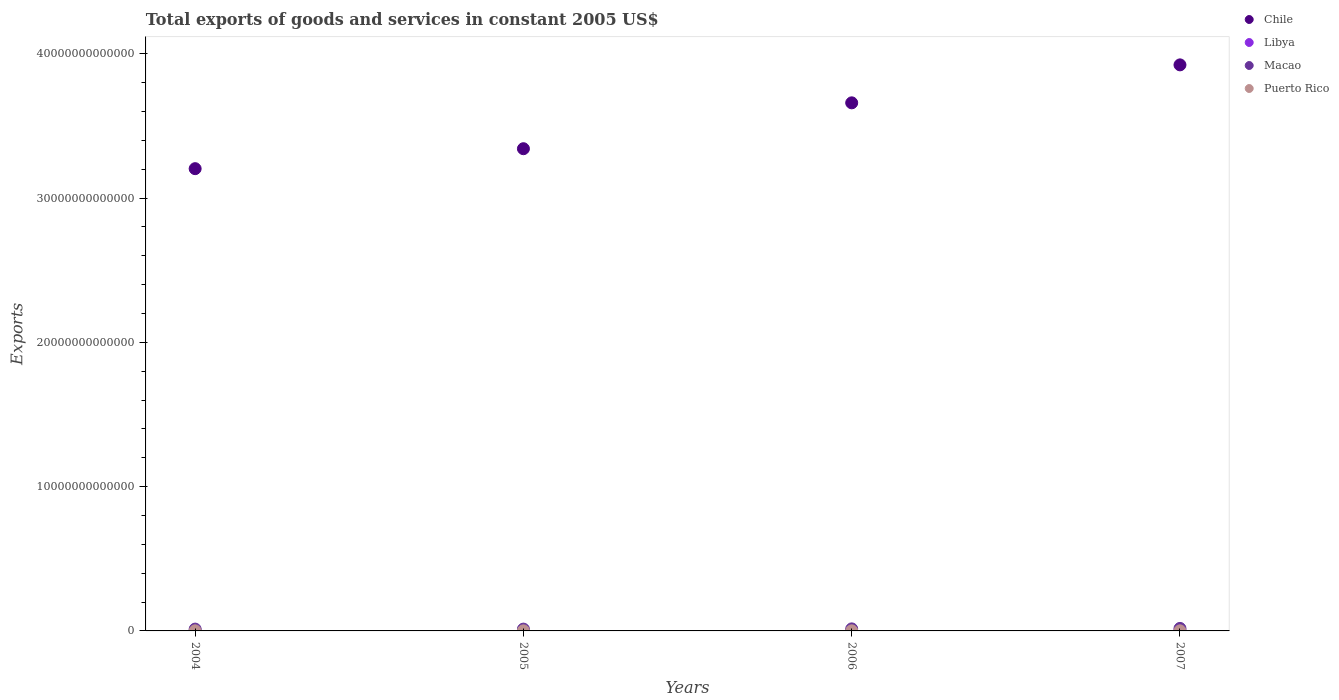How many different coloured dotlines are there?
Ensure brevity in your answer.  4. What is the total exports of goods and services in Chile in 2007?
Your response must be concise. 3.92e+13. Across all years, what is the maximum total exports of goods and services in Puerto Rico?
Your response must be concise. 7.64e+09. Across all years, what is the minimum total exports of goods and services in Chile?
Your response must be concise. 3.20e+13. In which year was the total exports of goods and services in Puerto Rico minimum?
Offer a very short reply. 2004. What is the total total exports of goods and services in Puerto Rico in the graph?
Your response must be concise. 2.89e+1. What is the difference between the total exports of goods and services in Libya in 2004 and that in 2005?
Offer a very short reply. -1.34e+09. What is the difference between the total exports of goods and services in Libya in 2004 and the total exports of goods and services in Chile in 2005?
Offer a very short reply. -3.34e+13. What is the average total exports of goods and services in Chile per year?
Offer a very short reply. 3.53e+13. In the year 2005, what is the difference between the total exports of goods and services in Libya and total exports of goods and services in Puerto Rico?
Ensure brevity in your answer.  1.15e+1. What is the ratio of the total exports of goods and services in Libya in 2004 to that in 2007?
Offer a terse response. 0.69. Is the difference between the total exports of goods and services in Libya in 2004 and 2005 greater than the difference between the total exports of goods and services in Puerto Rico in 2004 and 2005?
Offer a terse response. No. What is the difference between the highest and the second highest total exports of goods and services in Libya?
Offer a terse response. 2.36e+09. What is the difference between the highest and the lowest total exports of goods and services in Puerto Rico?
Provide a short and direct response. 6.37e+08. Is the sum of the total exports of goods and services in Libya in 2005 and 2007 greater than the maximum total exports of goods and services in Macao across all years?
Make the answer very short. No. Does the total exports of goods and services in Puerto Rico monotonically increase over the years?
Provide a succinct answer. No. Is the total exports of goods and services in Chile strictly greater than the total exports of goods and services in Libya over the years?
Ensure brevity in your answer.  Yes. Is the total exports of goods and services in Macao strictly less than the total exports of goods and services in Puerto Rico over the years?
Give a very brief answer. No. How many dotlines are there?
Give a very brief answer. 4. How many years are there in the graph?
Provide a succinct answer. 4. What is the difference between two consecutive major ticks on the Y-axis?
Provide a succinct answer. 1.00e+13. Does the graph contain any zero values?
Your answer should be compact. No. Does the graph contain grids?
Ensure brevity in your answer.  No. Where does the legend appear in the graph?
Make the answer very short. Top right. What is the title of the graph?
Provide a short and direct response. Total exports of goods and services in constant 2005 US$. What is the label or title of the Y-axis?
Offer a terse response. Exports. What is the Exports of Chile in 2004?
Offer a terse response. 3.20e+13. What is the Exports in Libya in 2004?
Provide a short and direct response. 1.74e+1. What is the Exports in Macao in 2004?
Your response must be concise. 1.26e+11. What is the Exports in Puerto Rico in 2004?
Keep it short and to the point. 7.00e+09. What is the Exports of Chile in 2005?
Provide a succinct answer. 3.34e+13. What is the Exports of Libya in 2005?
Offer a terse response. 1.87e+1. What is the Exports in Macao in 2005?
Your answer should be very brief. 1.25e+11. What is the Exports in Puerto Rico in 2005?
Offer a very short reply. 7.20e+09. What is the Exports of Chile in 2006?
Give a very brief answer. 3.66e+13. What is the Exports in Libya in 2006?
Give a very brief answer. 2.27e+1. What is the Exports of Macao in 2006?
Make the answer very short. 1.41e+11. What is the Exports of Puerto Rico in 2006?
Provide a succinct answer. 7.64e+09. What is the Exports in Chile in 2007?
Provide a short and direct response. 3.92e+13. What is the Exports in Libya in 2007?
Offer a terse response. 2.51e+1. What is the Exports in Macao in 2007?
Your response must be concise. 1.74e+11. What is the Exports in Puerto Rico in 2007?
Your answer should be compact. 7.04e+09. Across all years, what is the maximum Exports in Chile?
Your response must be concise. 3.92e+13. Across all years, what is the maximum Exports in Libya?
Give a very brief answer. 2.51e+1. Across all years, what is the maximum Exports of Macao?
Ensure brevity in your answer.  1.74e+11. Across all years, what is the maximum Exports in Puerto Rico?
Your answer should be compact. 7.64e+09. Across all years, what is the minimum Exports in Chile?
Your answer should be compact. 3.20e+13. Across all years, what is the minimum Exports in Libya?
Ensure brevity in your answer.  1.74e+1. Across all years, what is the minimum Exports of Macao?
Your answer should be compact. 1.25e+11. Across all years, what is the minimum Exports in Puerto Rico?
Your answer should be very brief. 7.00e+09. What is the total Exports in Chile in the graph?
Your response must be concise. 1.41e+14. What is the total Exports of Libya in the graph?
Provide a succinct answer. 8.38e+1. What is the total Exports in Macao in the graph?
Offer a very short reply. 5.67e+11. What is the total Exports of Puerto Rico in the graph?
Your answer should be compact. 2.89e+1. What is the difference between the Exports of Chile in 2004 and that in 2005?
Your response must be concise. -1.38e+12. What is the difference between the Exports in Libya in 2004 and that in 2005?
Keep it short and to the point. -1.34e+09. What is the difference between the Exports in Macao in 2004 and that in 2005?
Provide a short and direct response. 1.05e+09. What is the difference between the Exports of Puerto Rico in 2004 and that in 2005?
Provide a short and direct response. -1.94e+08. What is the difference between the Exports in Chile in 2004 and that in 2006?
Give a very brief answer. -4.56e+12. What is the difference between the Exports of Libya in 2004 and that in 2006?
Provide a short and direct response. -5.33e+09. What is the difference between the Exports of Macao in 2004 and that in 2006?
Keep it short and to the point. -1.50e+1. What is the difference between the Exports of Puerto Rico in 2004 and that in 2006?
Your response must be concise. -6.37e+08. What is the difference between the Exports in Chile in 2004 and that in 2007?
Make the answer very short. -7.19e+12. What is the difference between the Exports in Libya in 2004 and that in 2007?
Give a very brief answer. -7.70e+09. What is the difference between the Exports in Macao in 2004 and that in 2007?
Your answer should be very brief. -4.77e+1. What is the difference between the Exports in Puerto Rico in 2004 and that in 2007?
Keep it short and to the point. -3.23e+07. What is the difference between the Exports in Chile in 2005 and that in 2006?
Provide a short and direct response. -3.18e+12. What is the difference between the Exports of Libya in 2005 and that in 2006?
Offer a very short reply. -3.99e+09. What is the difference between the Exports in Macao in 2005 and that in 2006?
Provide a short and direct response. -1.60e+1. What is the difference between the Exports of Puerto Rico in 2005 and that in 2006?
Your answer should be very brief. -4.44e+08. What is the difference between the Exports of Chile in 2005 and that in 2007?
Your response must be concise. -5.81e+12. What is the difference between the Exports of Libya in 2005 and that in 2007?
Provide a short and direct response. -6.35e+09. What is the difference between the Exports of Macao in 2005 and that in 2007?
Offer a terse response. -4.87e+1. What is the difference between the Exports of Puerto Rico in 2005 and that in 2007?
Ensure brevity in your answer.  1.61e+08. What is the difference between the Exports in Chile in 2006 and that in 2007?
Your response must be concise. -2.63e+12. What is the difference between the Exports of Libya in 2006 and that in 2007?
Give a very brief answer. -2.36e+09. What is the difference between the Exports in Macao in 2006 and that in 2007?
Provide a succinct answer. -3.27e+1. What is the difference between the Exports in Puerto Rico in 2006 and that in 2007?
Your answer should be compact. 6.05e+08. What is the difference between the Exports in Chile in 2004 and the Exports in Libya in 2005?
Provide a short and direct response. 3.20e+13. What is the difference between the Exports of Chile in 2004 and the Exports of Macao in 2005?
Provide a short and direct response. 3.19e+13. What is the difference between the Exports in Chile in 2004 and the Exports in Puerto Rico in 2005?
Make the answer very short. 3.20e+13. What is the difference between the Exports in Libya in 2004 and the Exports in Macao in 2005?
Offer a very short reply. -1.08e+11. What is the difference between the Exports in Libya in 2004 and the Exports in Puerto Rico in 2005?
Offer a terse response. 1.02e+1. What is the difference between the Exports of Macao in 2004 and the Exports of Puerto Rico in 2005?
Provide a short and direct response. 1.19e+11. What is the difference between the Exports in Chile in 2004 and the Exports in Libya in 2006?
Offer a very short reply. 3.20e+13. What is the difference between the Exports of Chile in 2004 and the Exports of Macao in 2006?
Provide a succinct answer. 3.19e+13. What is the difference between the Exports of Chile in 2004 and the Exports of Puerto Rico in 2006?
Make the answer very short. 3.20e+13. What is the difference between the Exports in Libya in 2004 and the Exports in Macao in 2006?
Offer a terse response. -1.24e+11. What is the difference between the Exports of Libya in 2004 and the Exports of Puerto Rico in 2006?
Ensure brevity in your answer.  9.73e+09. What is the difference between the Exports of Macao in 2004 and the Exports of Puerto Rico in 2006?
Give a very brief answer. 1.19e+11. What is the difference between the Exports of Chile in 2004 and the Exports of Libya in 2007?
Your answer should be compact. 3.20e+13. What is the difference between the Exports of Chile in 2004 and the Exports of Macao in 2007?
Offer a very short reply. 3.19e+13. What is the difference between the Exports in Chile in 2004 and the Exports in Puerto Rico in 2007?
Your response must be concise. 3.20e+13. What is the difference between the Exports of Libya in 2004 and the Exports of Macao in 2007?
Your answer should be very brief. -1.57e+11. What is the difference between the Exports of Libya in 2004 and the Exports of Puerto Rico in 2007?
Provide a succinct answer. 1.03e+1. What is the difference between the Exports of Macao in 2004 and the Exports of Puerto Rico in 2007?
Make the answer very short. 1.19e+11. What is the difference between the Exports of Chile in 2005 and the Exports of Libya in 2006?
Your answer should be very brief. 3.34e+13. What is the difference between the Exports of Chile in 2005 and the Exports of Macao in 2006?
Your answer should be compact. 3.33e+13. What is the difference between the Exports of Chile in 2005 and the Exports of Puerto Rico in 2006?
Give a very brief answer. 3.34e+13. What is the difference between the Exports of Libya in 2005 and the Exports of Macao in 2006?
Provide a succinct answer. -1.23e+11. What is the difference between the Exports in Libya in 2005 and the Exports in Puerto Rico in 2006?
Your response must be concise. 1.11e+1. What is the difference between the Exports of Macao in 2005 and the Exports of Puerto Rico in 2006?
Provide a succinct answer. 1.18e+11. What is the difference between the Exports of Chile in 2005 and the Exports of Libya in 2007?
Your response must be concise. 3.34e+13. What is the difference between the Exports of Chile in 2005 and the Exports of Macao in 2007?
Offer a very short reply. 3.32e+13. What is the difference between the Exports of Chile in 2005 and the Exports of Puerto Rico in 2007?
Provide a succinct answer. 3.34e+13. What is the difference between the Exports in Libya in 2005 and the Exports in Macao in 2007?
Offer a very short reply. -1.55e+11. What is the difference between the Exports in Libya in 2005 and the Exports in Puerto Rico in 2007?
Offer a very short reply. 1.17e+1. What is the difference between the Exports in Macao in 2005 and the Exports in Puerto Rico in 2007?
Give a very brief answer. 1.18e+11. What is the difference between the Exports in Chile in 2006 and the Exports in Libya in 2007?
Ensure brevity in your answer.  3.66e+13. What is the difference between the Exports in Chile in 2006 and the Exports in Macao in 2007?
Provide a short and direct response. 3.64e+13. What is the difference between the Exports in Chile in 2006 and the Exports in Puerto Rico in 2007?
Your answer should be very brief. 3.66e+13. What is the difference between the Exports of Libya in 2006 and the Exports of Macao in 2007?
Offer a very short reply. -1.51e+11. What is the difference between the Exports in Libya in 2006 and the Exports in Puerto Rico in 2007?
Your answer should be compact. 1.57e+1. What is the difference between the Exports in Macao in 2006 and the Exports in Puerto Rico in 2007?
Make the answer very short. 1.34e+11. What is the average Exports in Chile per year?
Provide a succinct answer. 3.53e+13. What is the average Exports of Libya per year?
Provide a succinct answer. 2.10e+1. What is the average Exports in Macao per year?
Keep it short and to the point. 1.42e+11. What is the average Exports in Puerto Rico per year?
Your response must be concise. 7.22e+09. In the year 2004, what is the difference between the Exports in Chile and Exports in Libya?
Your answer should be very brief. 3.20e+13. In the year 2004, what is the difference between the Exports in Chile and Exports in Macao?
Ensure brevity in your answer.  3.19e+13. In the year 2004, what is the difference between the Exports of Chile and Exports of Puerto Rico?
Offer a terse response. 3.20e+13. In the year 2004, what is the difference between the Exports of Libya and Exports of Macao?
Your response must be concise. -1.09e+11. In the year 2004, what is the difference between the Exports in Libya and Exports in Puerto Rico?
Provide a succinct answer. 1.04e+1. In the year 2004, what is the difference between the Exports of Macao and Exports of Puerto Rico?
Provide a succinct answer. 1.19e+11. In the year 2005, what is the difference between the Exports of Chile and Exports of Libya?
Ensure brevity in your answer.  3.34e+13. In the year 2005, what is the difference between the Exports in Chile and Exports in Macao?
Offer a terse response. 3.33e+13. In the year 2005, what is the difference between the Exports of Chile and Exports of Puerto Rico?
Your answer should be compact. 3.34e+13. In the year 2005, what is the difference between the Exports in Libya and Exports in Macao?
Your response must be concise. -1.07e+11. In the year 2005, what is the difference between the Exports in Libya and Exports in Puerto Rico?
Offer a terse response. 1.15e+1. In the year 2005, what is the difference between the Exports of Macao and Exports of Puerto Rico?
Your response must be concise. 1.18e+11. In the year 2006, what is the difference between the Exports of Chile and Exports of Libya?
Provide a short and direct response. 3.66e+13. In the year 2006, what is the difference between the Exports in Chile and Exports in Macao?
Offer a very short reply. 3.65e+13. In the year 2006, what is the difference between the Exports in Chile and Exports in Puerto Rico?
Offer a terse response. 3.66e+13. In the year 2006, what is the difference between the Exports in Libya and Exports in Macao?
Provide a short and direct response. -1.19e+11. In the year 2006, what is the difference between the Exports in Libya and Exports in Puerto Rico?
Offer a very short reply. 1.51e+1. In the year 2006, what is the difference between the Exports in Macao and Exports in Puerto Rico?
Your answer should be compact. 1.34e+11. In the year 2007, what is the difference between the Exports in Chile and Exports in Libya?
Ensure brevity in your answer.  3.92e+13. In the year 2007, what is the difference between the Exports in Chile and Exports in Macao?
Your answer should be very brief. 3.91e+13. In the year 2007, what is the difference between the Exports in Chile and Exports in Puerto Rico?
Your response must be concise. 3.92e+13. In the year 2007, what is the difference between the Exports of Libya and Exports of Macao?
Your answer should be compact. -1.49e+11. In the year 2007, what is the difference between the Exports in Libya and Exports in Puerto Rico?
Make the answer very short. 1.80e+1. In the year 2007, what is the difference between the Exports of Macao and Exports of Puerto Rico?
Your answer should be compact. 1.67e+11. What is the ratio of the Exports in Chile in 2004 to that in 2005?
Ensure brevity in your answer.  0.96. What is the ratio of the Exports in Libya in 2004 to that in 2005?
Ensure brevity in your answer.  0.93. What is the ratio of the Exports of Macao in 2004 to that in 2005?
Your response must be concise. 1.01. What is the ratio of the Exports in Puerto Rico in 2004 to that in 2005?
Keep it short and to the point. 0.97. What is the ratio of the Exports of Chile in 2004 to that in 2006?
Offer a very short reply. 0.88. What is the ratio of the Exports of Libya in 2004 to that in 2006?
Your answer should be very brief. 0.77. What is the ratio of the Exports in Macao in 2004 to that in 2006?
Provide a succinct answer. 0.89. What is the ratio of the Exports of Puerto Rico in 2004 to that in 2006?
Make the answer very short. 0.92. What is the ratio of the Exports in Chile in 2004 to that in 2007?
Your response must be concise. 0.82. What is the ratio of the Exports of Libya in 2004 to that in 2007?
Provide a short and direct response. 0.69. What is the ratio of the Exports in Macao in 2004 to that in 2007?
Your answer should be very brief. 0.73. What is the ratio of the Exports of Puerto Rico in 2004 to that in 2007?
Your answer should be very brief. 1. What is the ratio of the Exports of Chile in 2005 to that in 2006?
Give a very brief answer. 0.91. What is the ratio of the Exports of Libya in 2005 to that in 2006?
Keep it short and to the point. 0.82. What is the ratio of the Exports in Macao in 2005 to that in 2006?
Your answer should be compact. 0.89. What is the ratio of the Exports of Puerto Rico in 2005 to that in 2006?
Keep it short and to the point. 0.94. What is the ratio of the Exports in Chile in 2005 to that in 2007?
Your response must be concise. 0.85. What is the ratio of the Exports in Libya in 2005 to that in 2007?
Give a very brief answer. 0.75. What is the ratio of the Exports in Macao in 2005 to that in 2007?
Provide a short and direct response. 0.72. What is the ratio of the Exports in Puerto Rico in 2005 to that in 2007?
Make the answer very short. 1.02. What is the ratio of the Exports in Chile in 2006 to that in 2007?
Your answer should be very brief. 0.93. What is the ratio of the Exports of Libya in 2006 to that in 2007?
Your response must be concise. 0.91. What is the ratio of the Exports of Macao in 2006 to that in 2007?
Ensure brevity in your answer.  0.81. What is the ratio of the Exports in Puerto Rico in 2006 to that in 2007?
Offer a very short reply. 1.09. What is the difference between the highest and the second highest Exports in Chile?
Ensure brevity in your answer.  2.63e+12. What is the difference between the highest and the second highest Exports in Libya?
Provide a succinct answer. 2.36e+09. What is the difference between the highest and the second highest Exports of Macao?
Give a very brief answer. 3.27e+1. What is the difference between the highest and the second highest Exports in Puerto Rico?
Offer a terse response. 4.44e+08. What is the difference between the highest and the lowest Exports in Chile?
Your answer should be compact. 7.19e+12. What is the difference between the highest and the lowest Exports of Libya?
Give a very brief answer. 7.70e+09. What is the difference between the highest and the lowest Exports of Macao?
Your answer should be very brief. 4.87e+1. What is the difference between the highest and the lowest Exports in Puerto Rico?
Ensure brevity in your answer.  6.37e+08. 